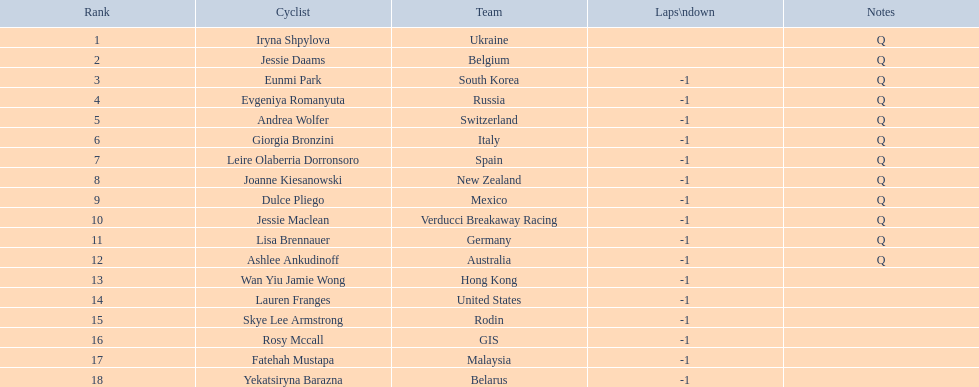Who are all the cyclists? Iryna Shpylova, Jessie Daams, Eunmi Park, Evgeniya Romanyuta, Andrea Wolfer, Giorgia Bronzini, Leire Olaberria Dorronsoro, Joanne Kiesanowski, Dulce Pliego, Jessie Maclean, Lisa Brennauer, Ashlee Ankudinoff, Wan Yiu Jamie Wong, Lauren Franges, Skye Lee Armstrong, Rosy Mccall, Fatehah Mustapa, Yekatsiryna Barazna. What were their ranks? 1, 2, 3, 4, 5, 6, 7, 8, 9, 10, 11, 12, 13, 14, 15, 16, 17, 18. Who was ranked highest? Iryna Shpylova. 